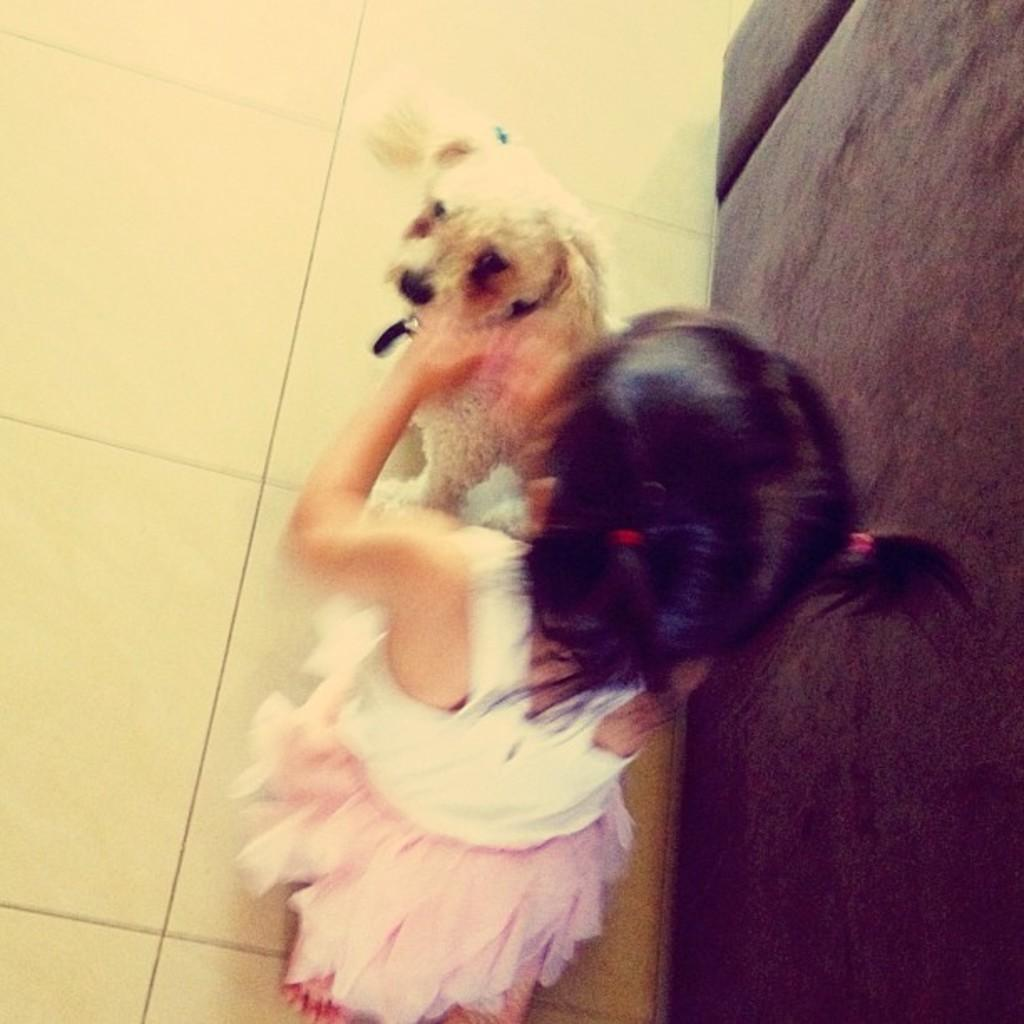Who is the main subject in the image? There is a girl in the image. What is the girl doing in the image? The girl is sitting on her knees. Is there any other living creature in the image? Yes, there is a dog in the image. Where does the scene take place? The scene takes place on the floor. What type of connection can be seen between the girl and the dog in the image? There is no visible connection between the girl and the dog in the image; they are simply both present in the scene. 